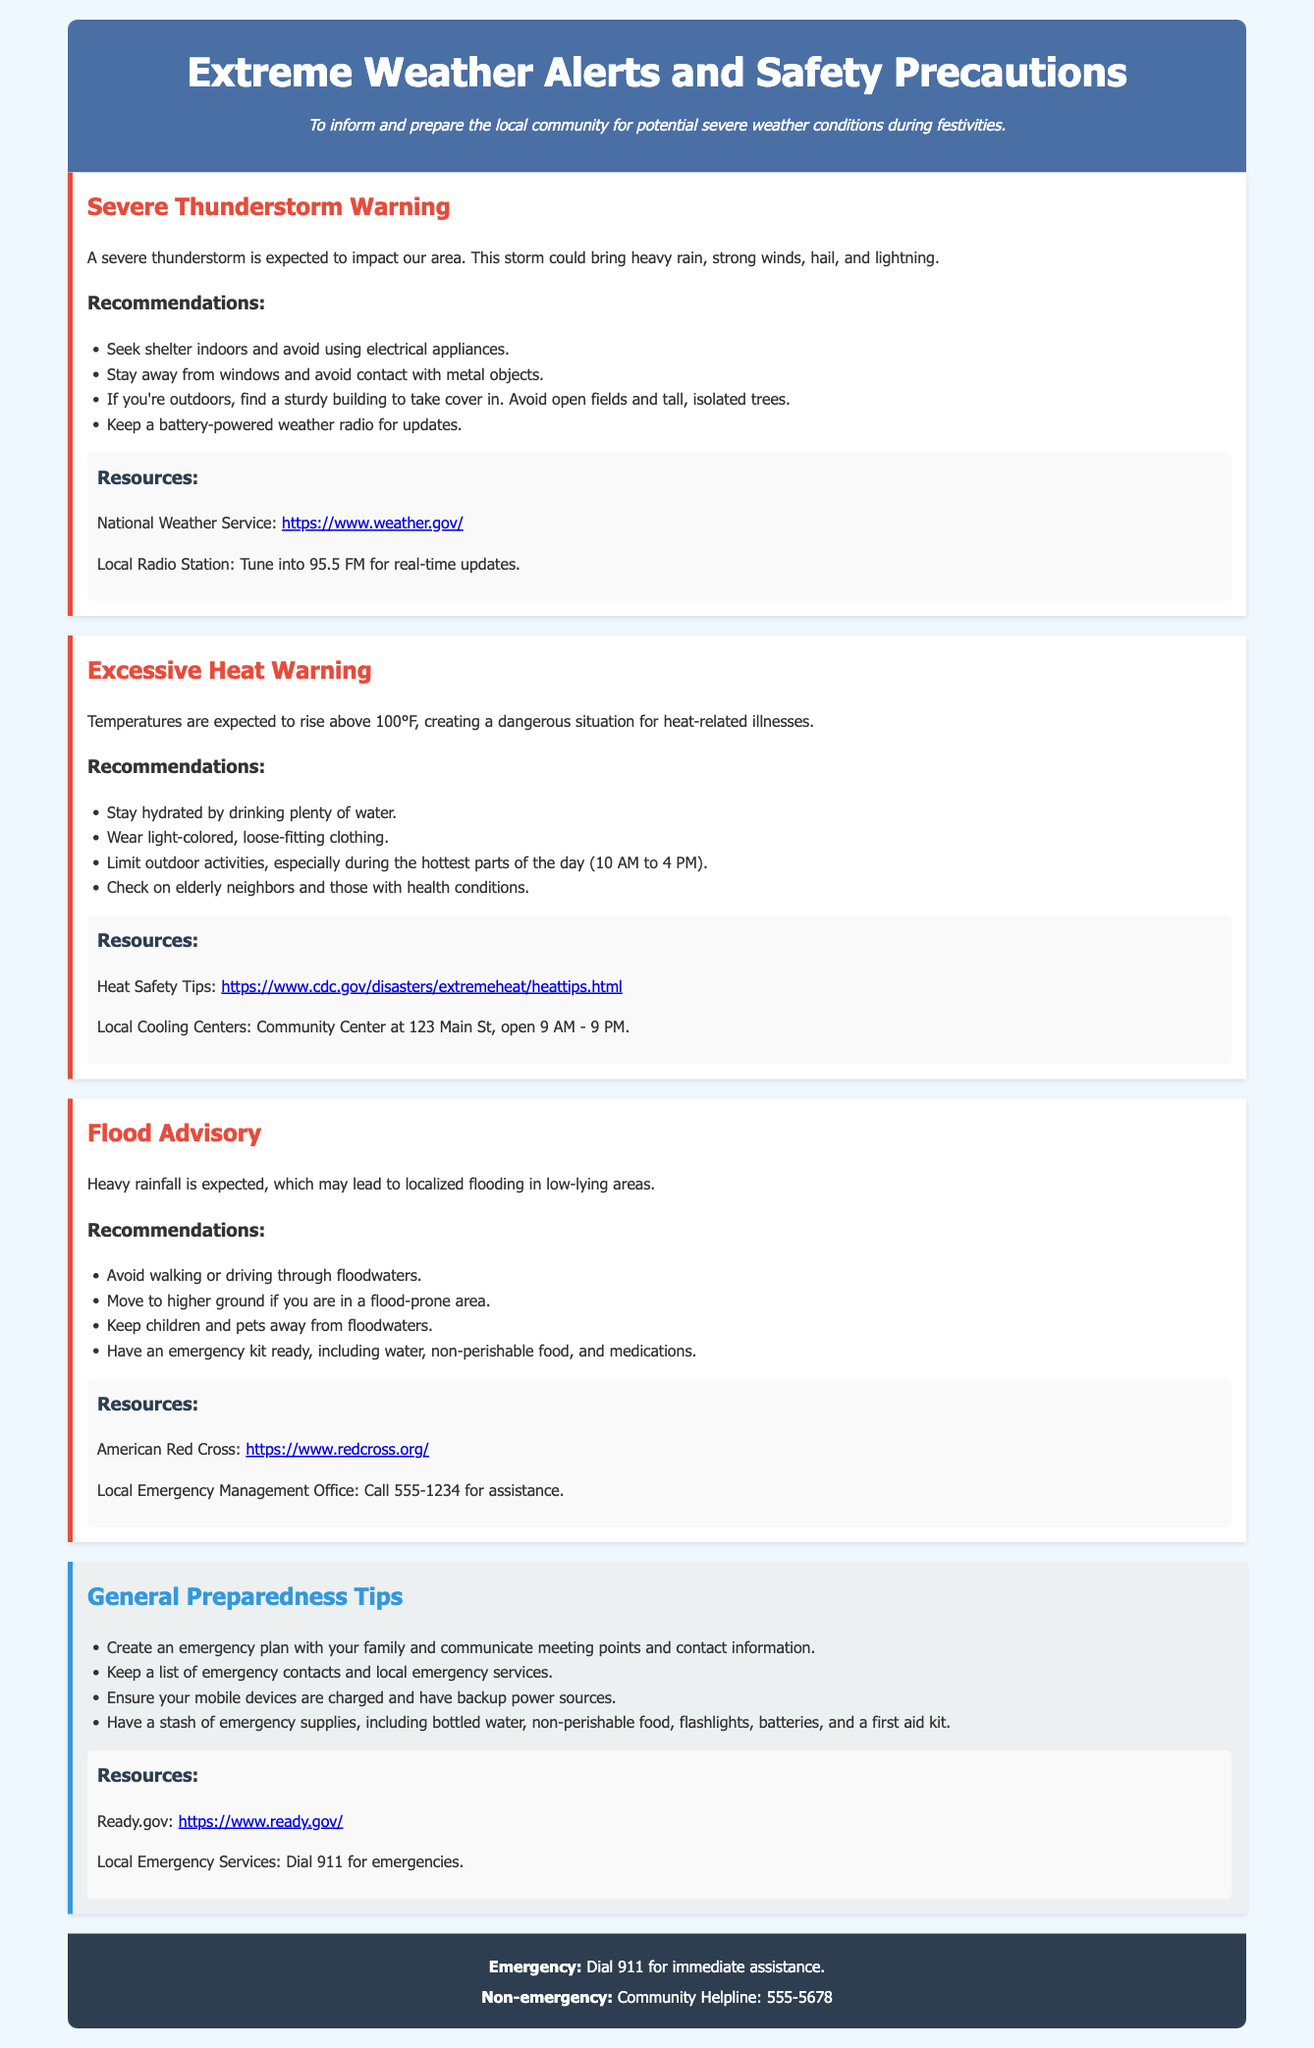What is the temperature expected during the Excessive Heat Warning? The document states that temperatures are expected to rise above 100°F.
Answer: above 100°F What should you avoid during a Severe Thunderstorm? One of the recommendations states to avoid using electrical appliances during a thunderstorm.
Answer: electrical appliances What should you check on during an Excessive Heat Warning? The document advises to check on elderly neighbors and those with health conditions.
Answer: elderly neighbors What is the main purpose of this document? The purpose of the document is to inform and prepare the local community for potential severe weather conditions during festivities.
Answer: inform and prepare the local community What is the contact number for the Community Helpline? The footer of the document provides the Community Helpline number as 555-5678.
Answer: 555-5678 What should you do if you are in a flood-prone area? The document recommends moving to higher ground if in a flood-prone area.
Answer: move to higher ground Which agency provides the National Weather Service link? The document mentions the National Weather Service link, which is provided by the government agency focused on weather.
Answer: National Weather Service How can you stay updated during a Severe Thunderstorm? The document recommends keeping a battery-powered weather radio for updates.
Answer: battery-powered weather radio 